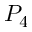Convert formula to latex. <formula><loc_0><loc_0><loc_500><loc_500>P _ { 4 }</formula> 